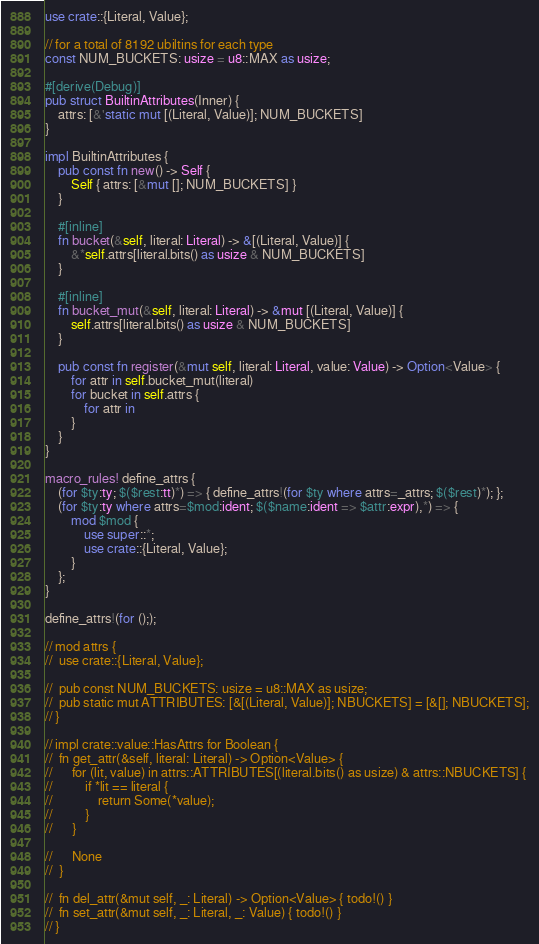<code> <loc_0><loc_0><loc_500><loc_500><_Rust_>use crate::{Literal, Value};

// for a total of 8192 ubiltins for each type
const NUM_BUCKETS: usize = u8::MAX as usize;

#[derive(Debug)]
pub struct BuiltinAttributes(Inner) {
	attrs: [&'static mut [(Literal, Value)]; NUM_BUCKETS]
}

impl BuiltinAttributes {
	pub const fn new() -> Self {
		Self { attrs: [&mut []; NUM_BUCKETS] }
	}

	#[inline]
	fn bucket(&self, literal: Literal) -> &[(Literal, Value)] {
		&*self.attrs[literal.bits() as usize & NUM_BUCKETS]
	}

	#[inline]
	fn bucket_mut(&self, literal: Literal) -> &mut [(Literal, Value)] {
		self.attrs[literal.bits() as usize & NUM_BUCKETS]
	}

	pub const fn register(&mut self, literal: Literal, value: Value) -> Option<Value> {
		for attr in self.bucket_mut(literal)
		for bucket in self.attrs {
			for attr in 
		}
	}
}

macro_rules! define_attrs {
	(for $ty:ty; $($rest:tt)*) => { define_attrs!(for $ty where attrs=_attrs; $($rest)*); };
	(for $ty:ty where attrs=$mod:ident; $($name:ident => $attr:expr),*) => {
		mod $mod {
			use super::*;
			use crate::{Literal, Value};
		}
	};
}

define_attrs!(for (););

// mod attrs {
// 	use crate::{Literal, Value};

// 	pub const NUM_BUCKETS: usize = u8::MAX as usize;
// 	pub static mut ATTRIBUTES: [&[(Literal, Value)]; NBUCKETS] = [&[]; NBUCKETS];
// }

// impl crate::value::HasAttrs for Boolean {
// 	fn get_attr(&self, literal: Literal) -> Option<Value> {
// 		for (lit, value) in attrs::ATTRIBUTES[(literal.bits() as usize) & attrs::NBUCKETS] {
// 			if *lit == literal {
// 				return Some(*value);
// 			}
// 		}

// 		None
// 	}

// 	fn del_attr(&mut self, _: Literal) -> Option<Value> { todo!() }
// 	fn set_attr(&mut self, _: Literal, _: Value) { todo!() }
// }
</code> 